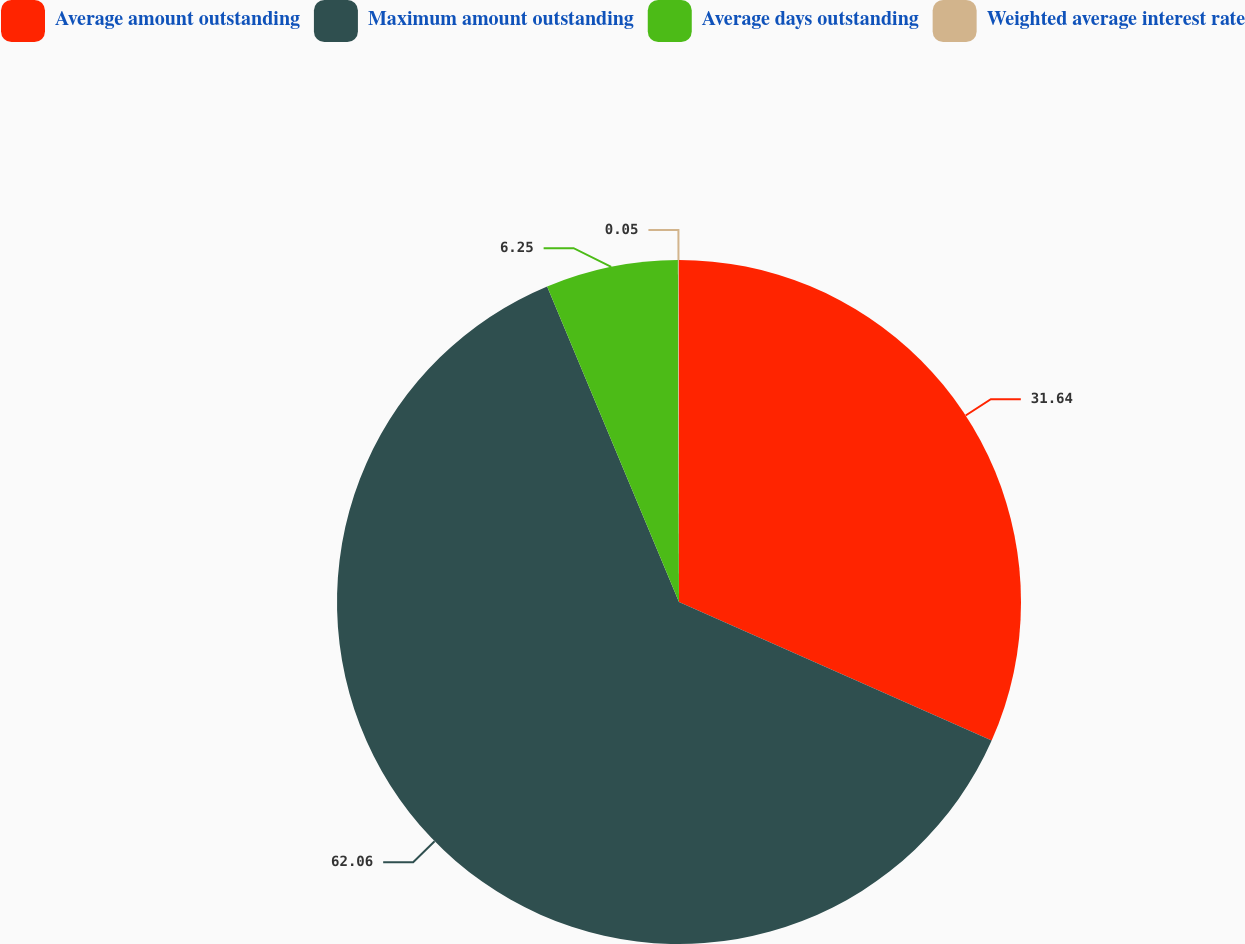Convert chart. <chart><loc_0><loc_0><loc_500><loc_500><pie_chart><fcel>Average amount outstanding<fcel>Maximum amount outstanding<fcel>Average days outstanding<fcel>Weighted average interest rate<nl><fcel>31.64%<fcel>62.06%<fcel>6.25%<fcel>0.05%<nl></chart> 